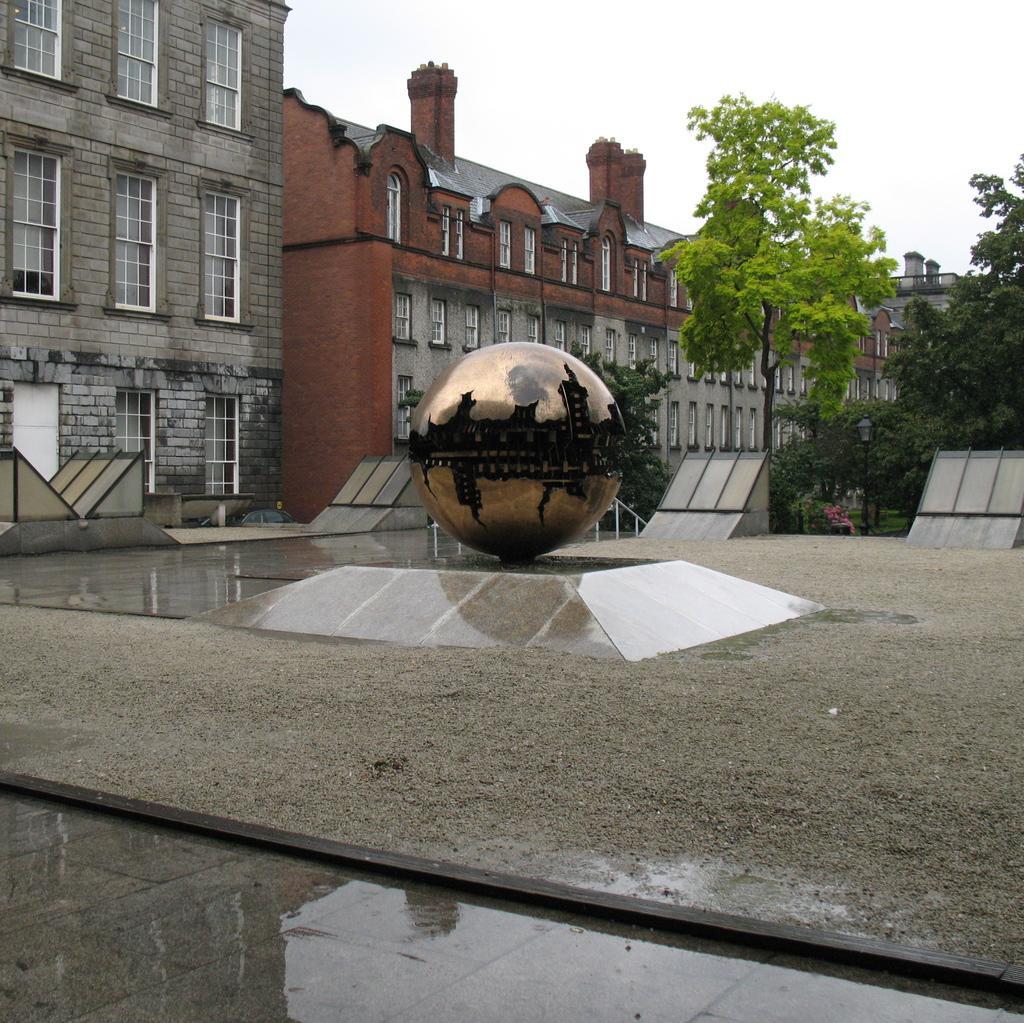Can you describe this image briefly? In this picture we can see circular object on the platform, ground, trees, buildings, windows and objects. In the background of the image we can see the sky. 